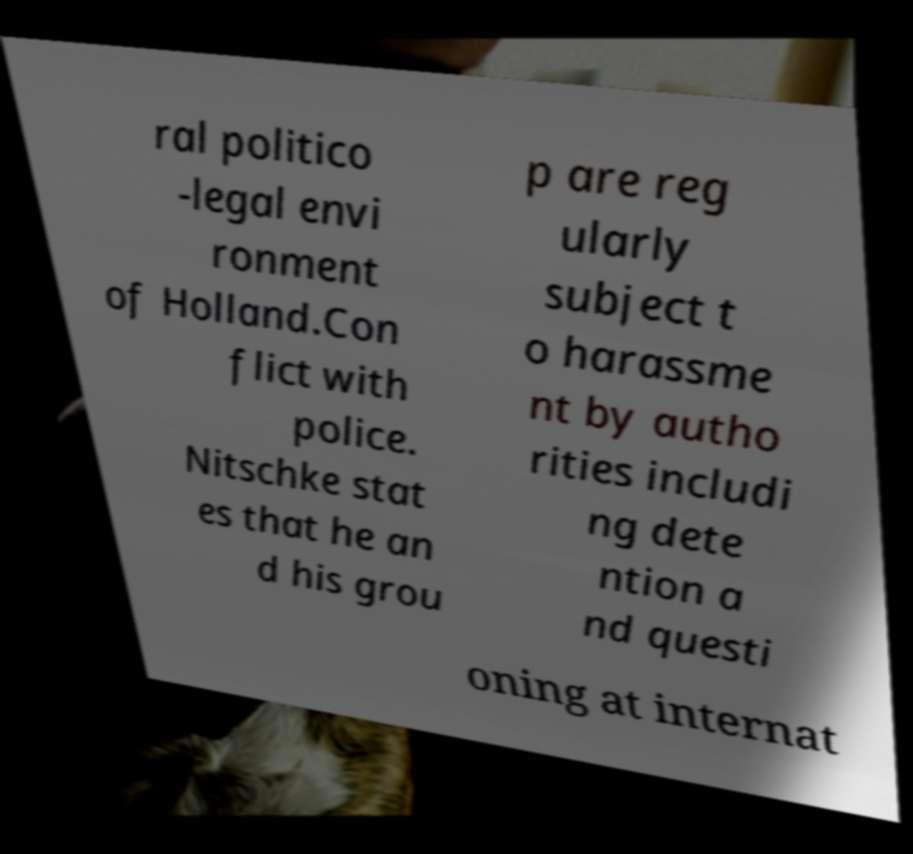Could you extract and type out the text from this image? ral politico -legal envi ronment of Holland.Con flict with police. Nitschke stat es that he an d his grou p are reg ularly subject t o harassme nt by autho rities includi ng dete ntion a nd questi oning at internat 